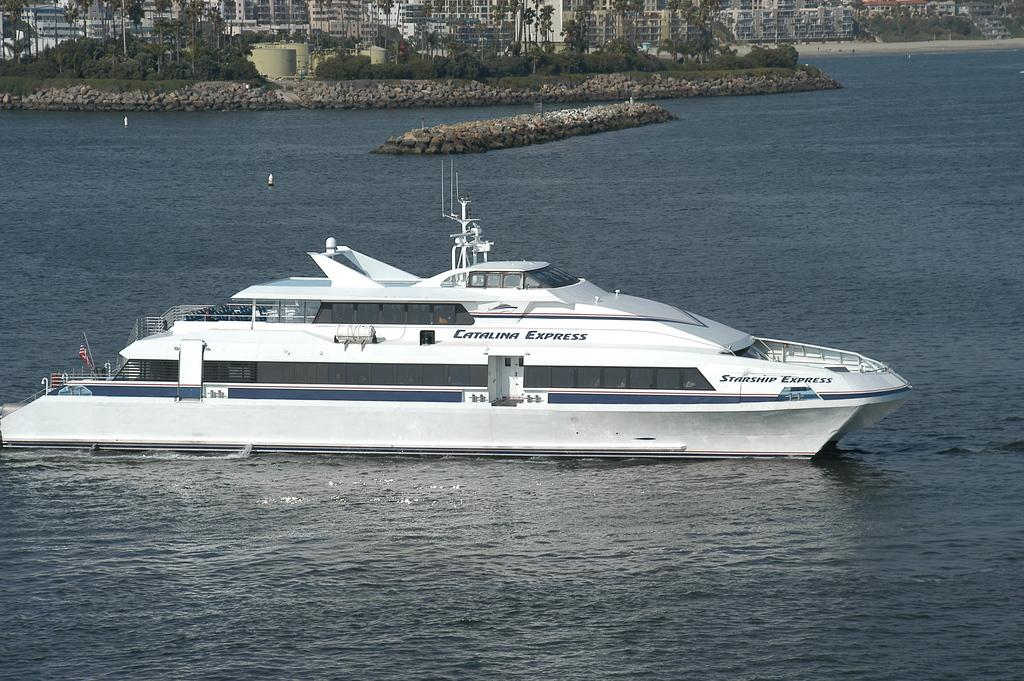What is the main subject of the image? The main subject of the image is a ship in the water. What type of natural elements can be seen in the image? There are stones and trees visible in the image. What type of man-made structures can be seen in the image? There are buildings visible in the image. What type of nation is depicted on the ship's flag in the image? There is no flag visible on the ship in the image, so it is not possible to determine the type of nation. Can you see any guns or weaponry in the image? There are no guns or weaponry visible in the image. What type of material is the cork made of in the image? There is no cork present in the image. 